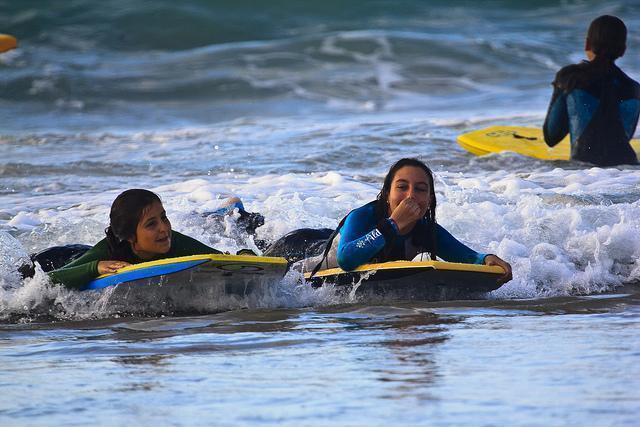Why are they lying down?
Make your selection from the four choices given to correctly answer the question.
Options: To hide, to relax, to hunt, to sleep. To relax. 